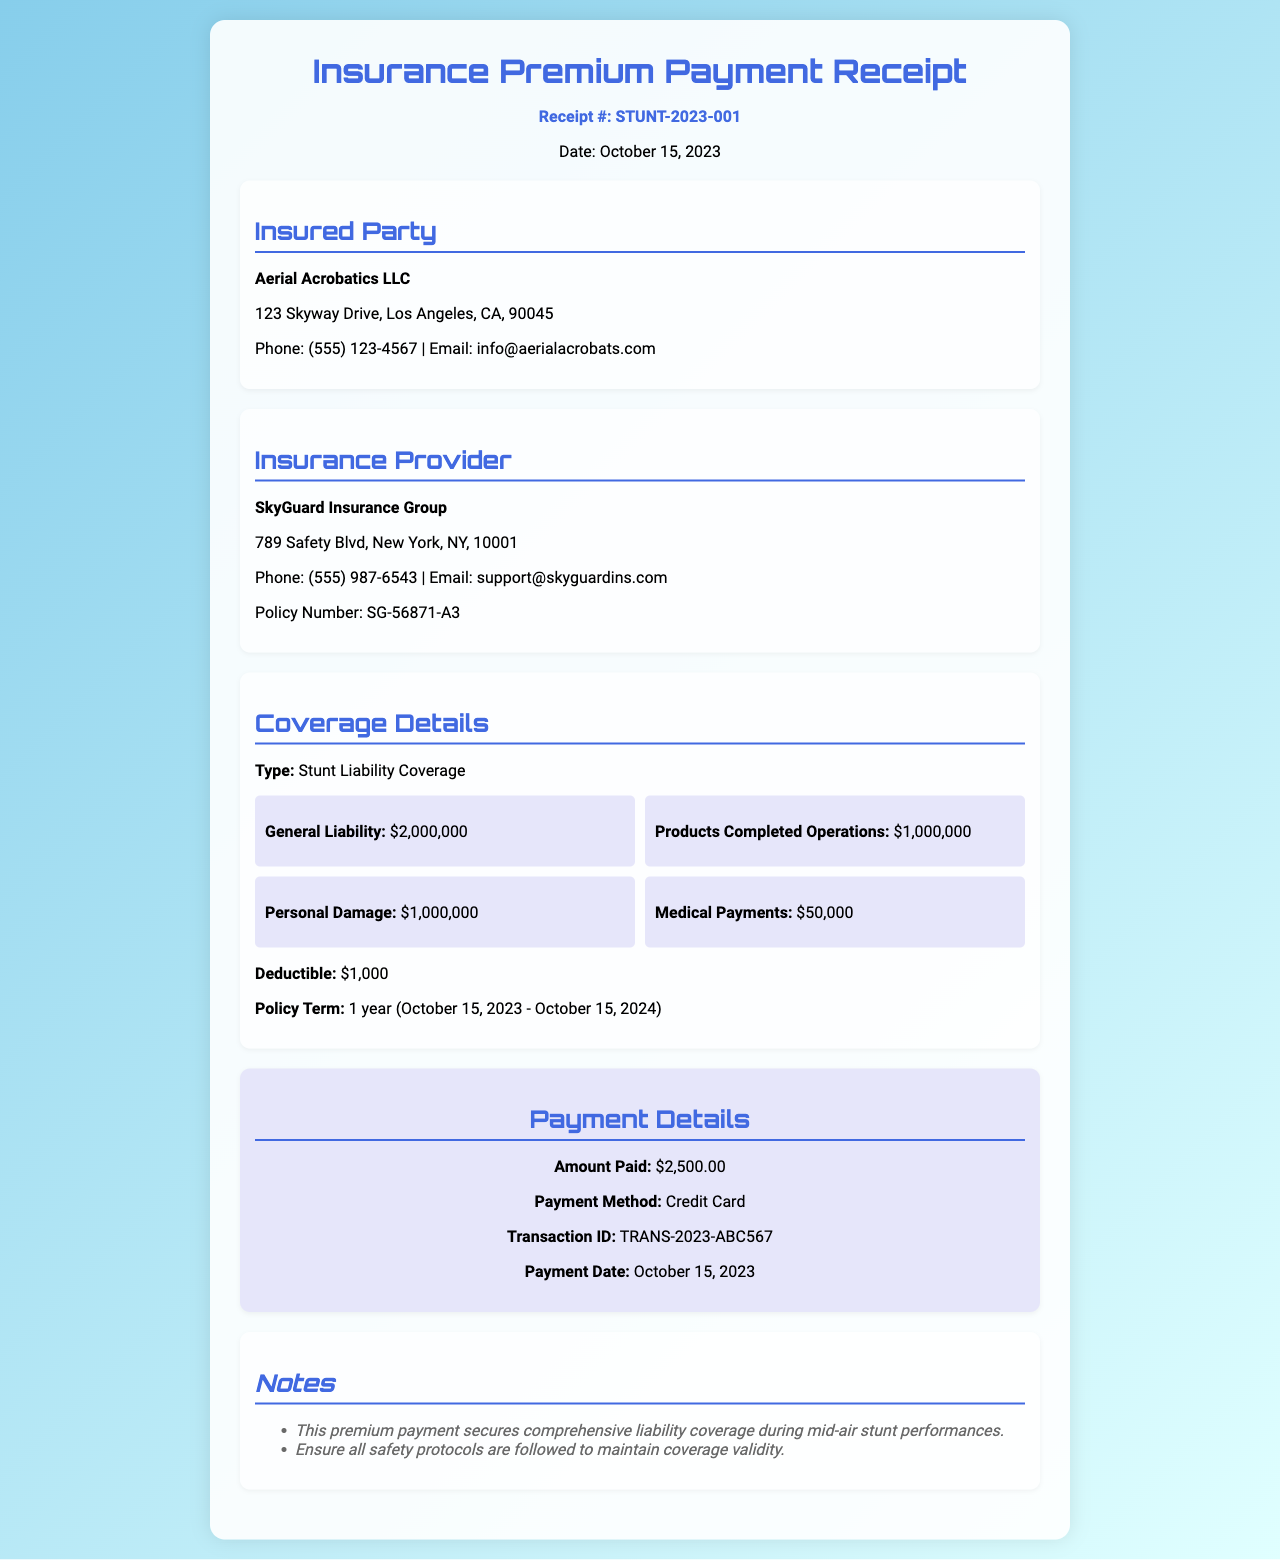What is the receipt number? The receipt number is clearly mentioned in the document as "Receipt #: STUNT-2023-001."
Answer: STUNT-2023-001 What is the date of the payment? The payment date is stated in the receipt as "Date: October 15, 2023."
Answer: October 15, 2023 Who is the insured party? The document specifies the insured party as "Aerial Acrobatics LLC."
Answer: Aerial Acrobatics LLC What is the amount paid for the insurance premium? The document states the payment amount as "Amount Paid: $2,500.00."
Answer: $2,500.00 What is the deductible amount? The deductible amount indicated in the coverage details is "$1,000."
Answer: $1,000 What is the general liability coverage limit? The general liability coverage limit is listed as "$2,000,000."
Answer: $2,000,000 Who is the insurance provider? The insurance provider mentioned in the document is "SkyGuard Insurance Group."
Answer: SkyGuard Insurance Group What is the policy term duration? The policy term duration is specified as "1 year (October 15, 2023 - October 15, 2024)."
Answer: 1 year (October 15, 2023 - October 15, 2024) Is medical payments coverage included? The document mentions "Medical Payments: $50,000," indicating its inclusion in the coverage.
Answer: Yes 